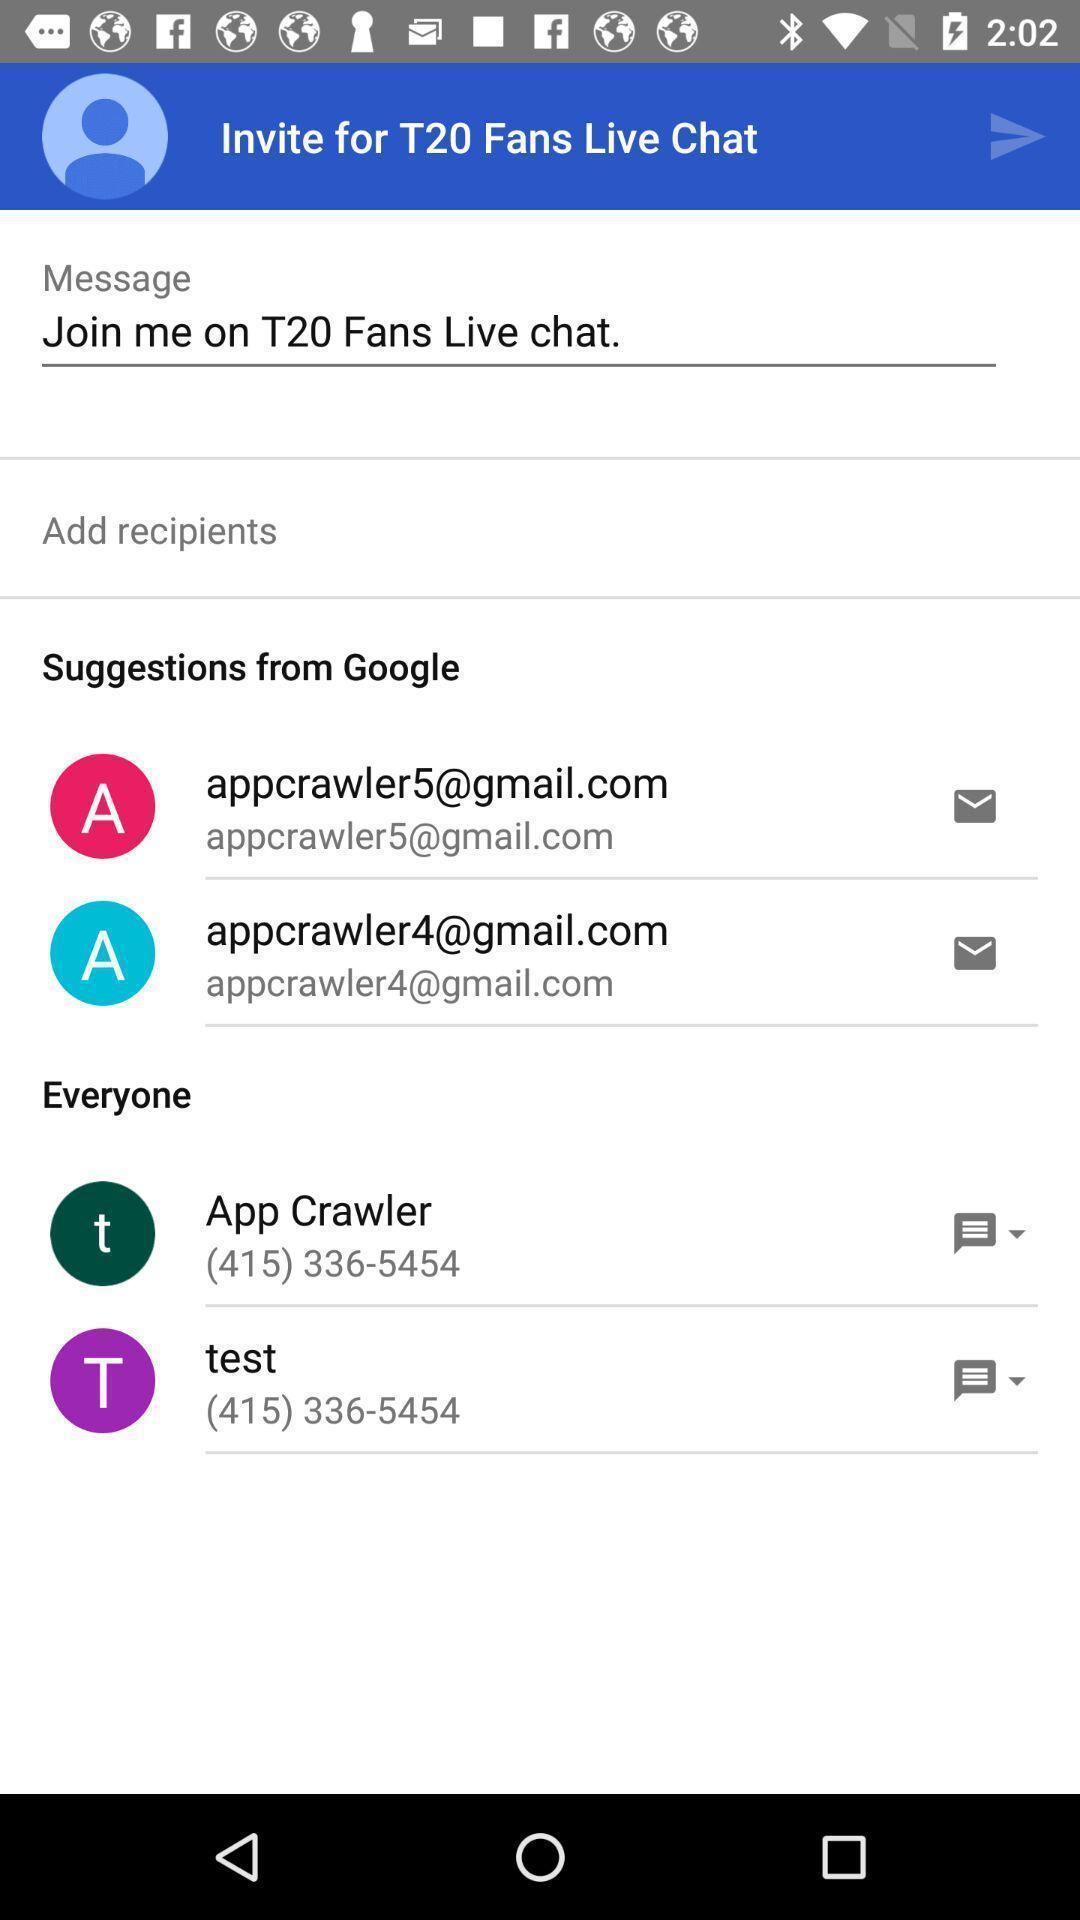Summarize the main components in this picture. Screen shows a live chat of cricket fans. 